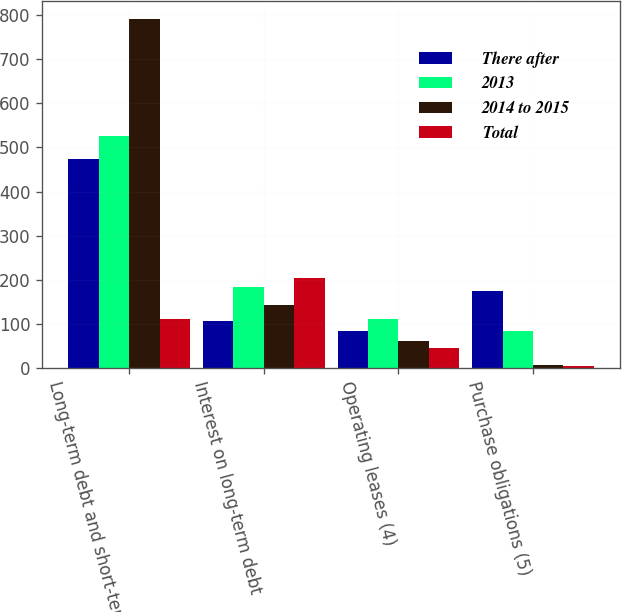Convert chart. <chart><loc_0><loc_0><loc_500><loc_500><stacked_bar_chart><ecel><fcel>Long-term debt and short-term<fcel>Interest on long-term debt<fcel>Operating leases (4)<fcel>Purchase obligations (5)<nl><fcel>There after<fcel>474<fcel>106<fcel>83<fcel>175<nl><fcel>2013<fcel>526<fcel>184<fcel>112<fcel>84<nl><fcel>2014 to 2015<fcel>792<fcel>143<fcel>60<fcel>6<nl><fcel>Total<fcel>112<fcel>205<fcel>45<fcel>5<nl></chart> 